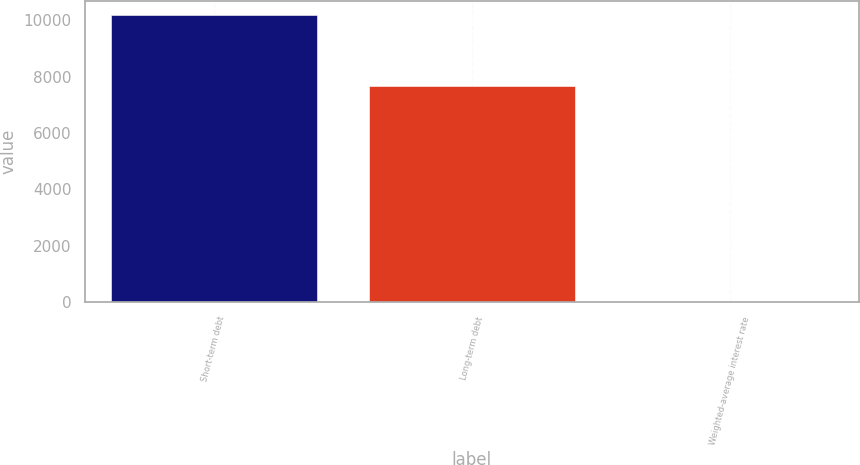Convert chart. <chart><loc_0><loc_0><loc_500><loc_500><bar_chart><fcel>Short-term debt<fcel>Long-term debt<fcel>Weighted-average interest rate<nl><fcel>10176<fcel>7676<fcel>3.6<nl></chart> 